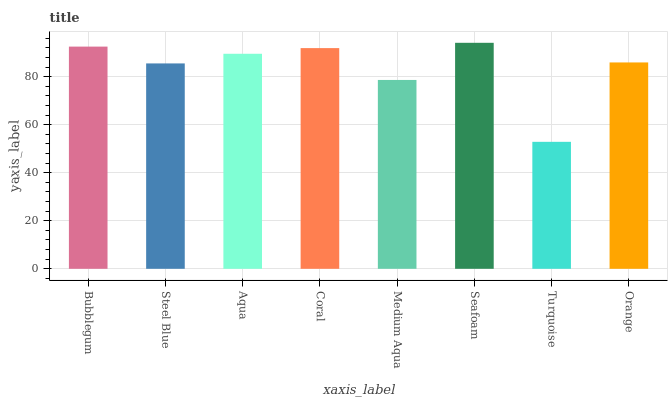Is Turquoise the minimum?
Answer yes or no. Yes. Is Seafoam the maximum?
Answer yes or no. Yes. Is Steel Blue the minimum?
Answer yes or no. No. Is Steel Blue the maximum?
Answer yes or no. No. Is Bubblegum greater than Steel Blue?
Answer yes or no. Yes. Is Steel Blue less than Bubblegum?
Answer yes or no. Yes. Is Steel Blue greater than Bubblegum?
Answer yes or no. No. Is Bubblegum less than Steel Blue?
Answer yes or no. No. Is Aqua the high median?
Answer yes or no. Yes. Is Orange the low median?
Answer yes or no. Yes. Is Orange the high median?
Answer yes or no. No. Is Seafoam the low median?
Answer yes or no. No. 